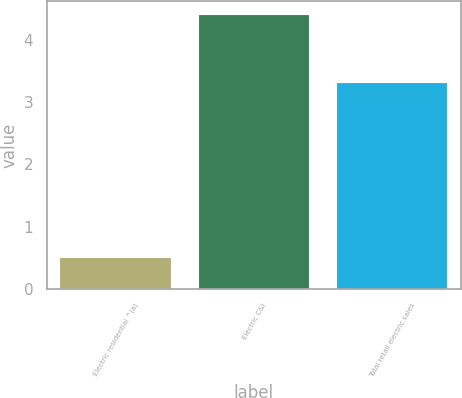Convert chart. <chart><loc_0><loc_0><loc_500><loc_500><bar_chart><fcel>Electric residential ^(a)<fcel>Electric C&I<fcel>Total retail electric sales<nl><fcel>0.5<fcel>4.4<fcel>3.3<nl></chart> 